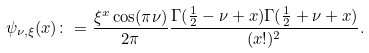<formula> <loc_0><loc_0><loc_500><loc_500>\psi _ { \nu , \xi } ( x ) \colon = \frac { \xi ^ { x } \cos ( \pi \nu ) } { 2 \pi } \frac { \Gamma ( \frac { 1 } { 2 } - \nu + x ) \Gamma ( \frac { 1 } { 2 } + \nu + x ) } { ( x ! ) ^ { 2 } } .</formula> 